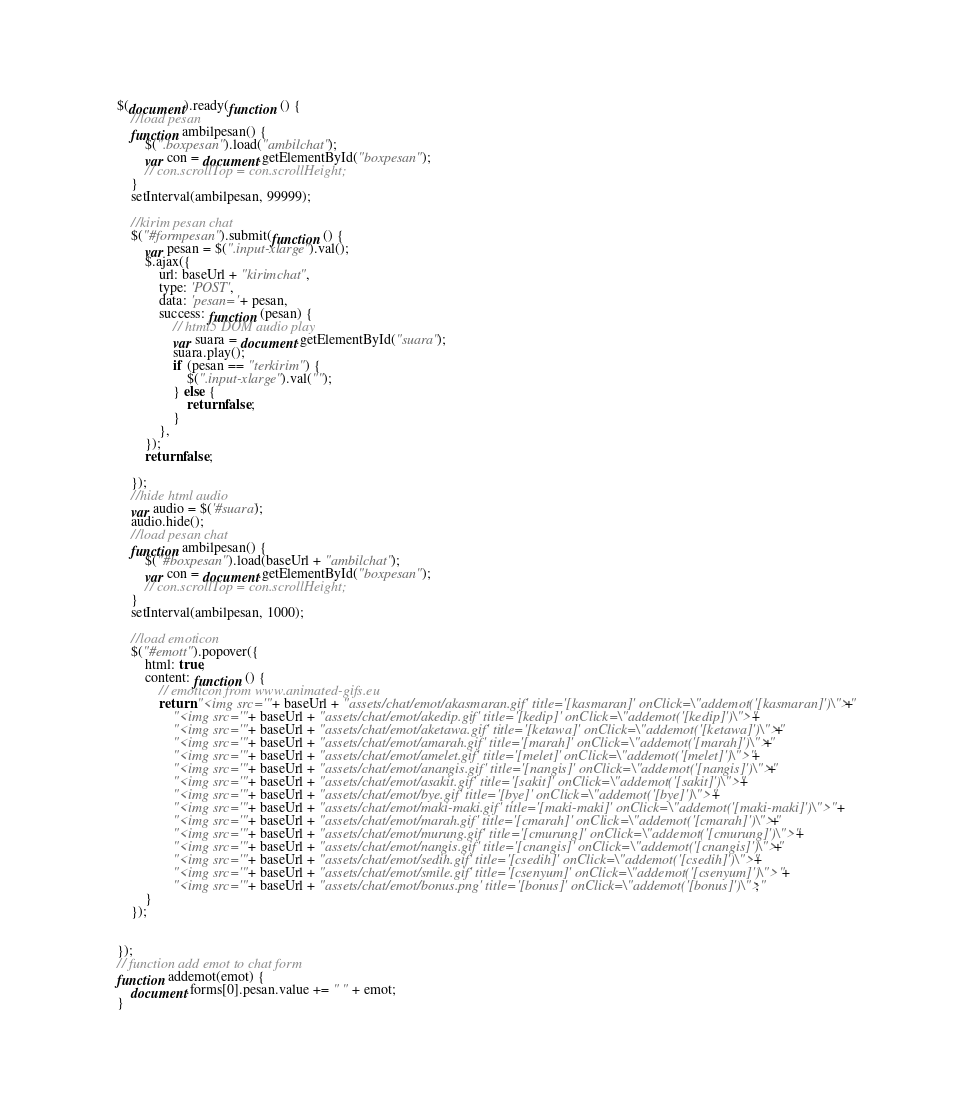Convert code to text. <code><loc_0><loc_0><loc_500><loc_500><_JavaScript_>$(document).ready(function () {
	//load pesan
	function ambilpesan() {
		$(".boxpesan").load("ambilchat");
		var con = document.getElementById("boxpesan");
		// con.scrollTop = con.scrollHeight;
	}
	setInterval(ambilpesan, 99999);

	//kirim pesan chat
	$("#formpesan").submit(function () {
		var pesan = $(".input-xlarge").val();
		$.ajax({
			url: baseUrl + "kirimchat",
			type: 'POST',
			data: 'pesan=' + pesan,
			success: function (pesan) {
				// html5 DOM audio play
				var suara = document.getElementById("suara");
				suara.play();
				if (pesan == "terkirim") {
					$(".input-xlarge").val("");
				} else {
					return false;
				}
			},
		});
		return false;

	});
	//hide html audio
	var audio = $('#suara');
	audio.hide();
	//load pesan chat
	function ambilpesan() {
		$("#boxpesan").load(baseUrl + "ambilchat");
		var con = document.getElementById("boxpesan");
		// con.scrollTop = con.scrollHeight;
	}
	setInterval(ambilpesan, 1000);

	//load emoticon
	$("#emott").popover({
		html: true,
		content: function () {
			// emoticon from www.animated-gifs.eu
			return "<img src='" + baseUrl + "assets/chat/emot/akasmaran.gif' title='[kasmaran]' onClick=\"addemot('[kasmaran]')\">" +
				"<img src='" + baseUrl + "assets/chat/emot/akedip.gif' title='[kedip]' onClick=\"addemot('[kedip]')\">" +
				"<img src='" + baseUrl + "assets/chat/emot/aketawa.gif' title='[ketawa]' onClick=\"addemot('[ketawa]')\">" +
				"<img src='" + baseUrl + "assets/chat/emot/amarah.gif' title='[marah]' onClick=\"addemot('[marah]')\">" +
				"<img src='" + baseUrl + "assets/chat/emot/amelet.gif' title='[melet]' onClick=\"addemot('[melet]')\">" +
				"<img src='" + baseUrl + "assets/chat/emot/anangis.gif' title='[nangis]' onClick=\"addemot('[nangis]')\">" +
				"<img src='" + baseUrl + "assets/chat/emot/asakit.gif' title='[sakit]' onClick=\"addemot('[sakit]')\">" +
				"<img src='" + baseUrl + "assets/chat/emot/bye.gif' title='[bye]' onClick=\"addemot('[bye]')\">" +
				"<img src='" + baseUrl + "assets/chat/emot/maki-maki.gif' title='[maki-maki]' onClick=\"addemot('[maki-maki]')\">" +
				"<img src='" + baseUrl + "assets/chat/emot/marah.gif' title='[cmarah]' onClick=\"addemot('[cmarah]')\">" +
				"<img src='" + baseUrl + "assets/chat/emot/murung.gif' title='[cmurung]' onClick=\"addemot('[cmurung]')\">" +
				"<img src='" + baseUrl + "assets/chat/emot/nangis.gif' title='[cnangis]' onClick=\"addemot('[cnangis]')\">" +
				"<img src='" + baseUrl + "assets/chat/emot/sedih.gif' title='[csedih]' onClick=\"addemot('[csedih]')\">" +
				"<img src='" + baseUrl + "assets/chat/emot/smile.gif' title='[csenyum]' onClick=\"addemot('[csenyum]')\">" +
				"<img src='" + baseUrl + "assets/chat/emot/bonus.png' title='[bonus]' onClick=\"addemot('[bonus]')\">";
		}
	});


});
// function add emot to chat form
function addemot(emot) {
	document.forms[0].pesan.value += " " + emot;
}
</code> 